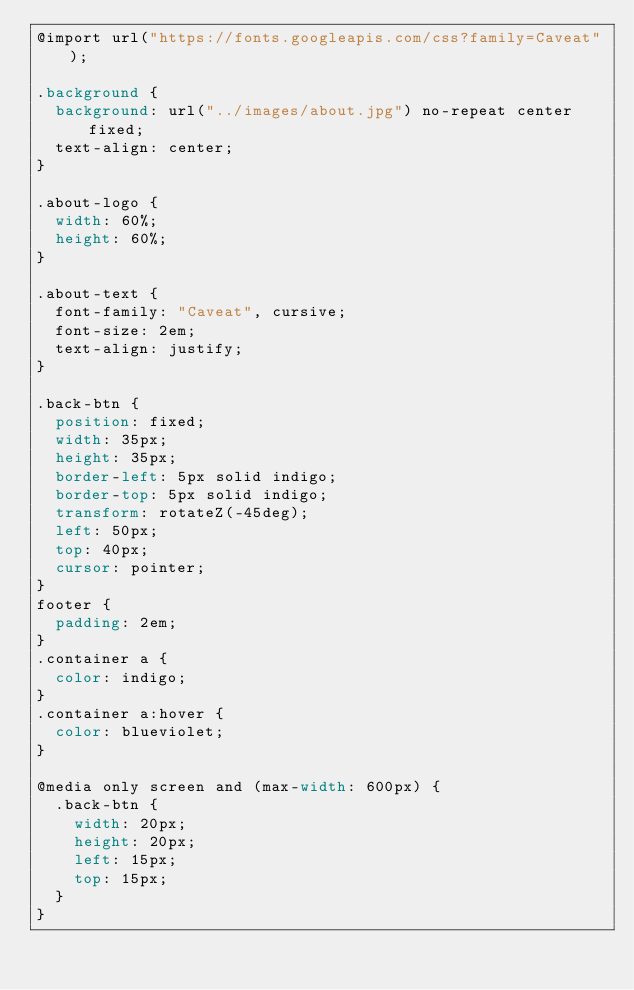<code> <loc_0><loc_0><loc_500><loc_500><_CSS_>@import url("https://fonts.googleapis.com/css?family=Caveat");

.background {
  background: url("../images/about.jpg") no-repeat center fixed;
  text-align: center;
}

.about-logo {
  width: 60%;
  height: 60%;
}

.about-text {
  font-family: "Caveat", cursive;
  font-size: 2em;
  text-align: justify;
}

.back-btn {
  position: fixed;
  width: 35px;
  height: 35px;
  border-left: 5px solid indigo;
  border-top: 5px solid indigo;
  transform: rotateZ(-45deg);
  left: 50px;
  top: 40px;
  cursor: pointer;
}
footer {
  padding: 2em;
}
.container a {
  color: indigo;
}
.container a:hover {
  color: blueviolet;
}

@media only screen and (max-width: 600px) {
  .back-btn {
    width: 20px;
    height: 20px;
    left: 15px;
    top: 15px;
  }
}
</code> 